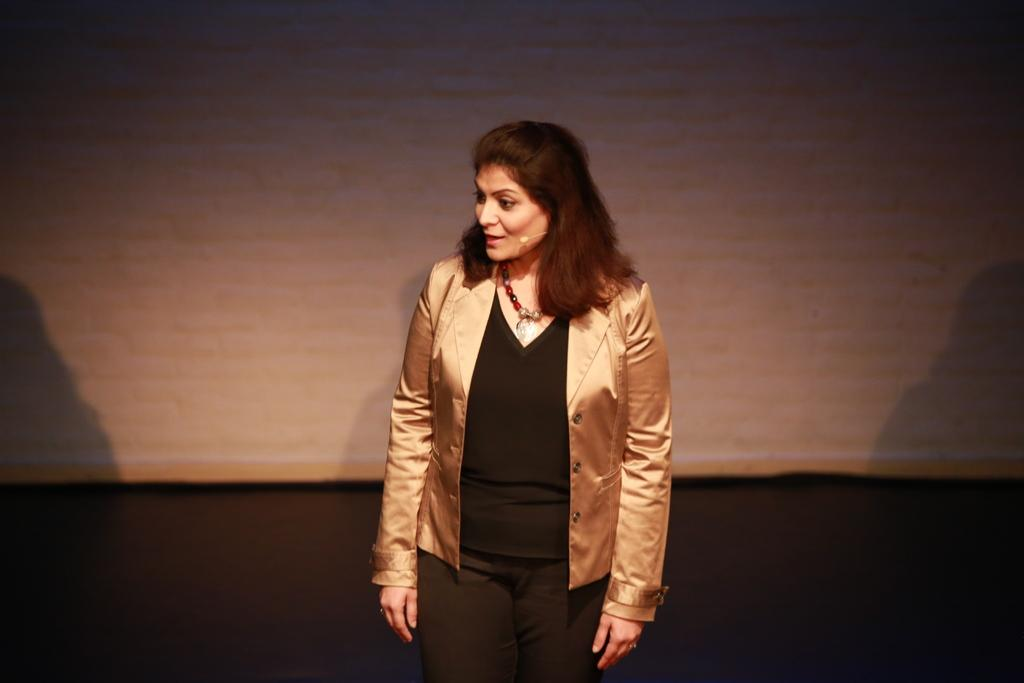Who is the main subject in the image? There is a woman in the image. What is the woman wearing? The woman is wearing a gold color coat and a black color dress. What is the woman doing in the image? The woman is talking into a microphone. What type of noise is the woman making with the cream in the image? There is no cream present in the image, and therefore no such activity can be observed. 